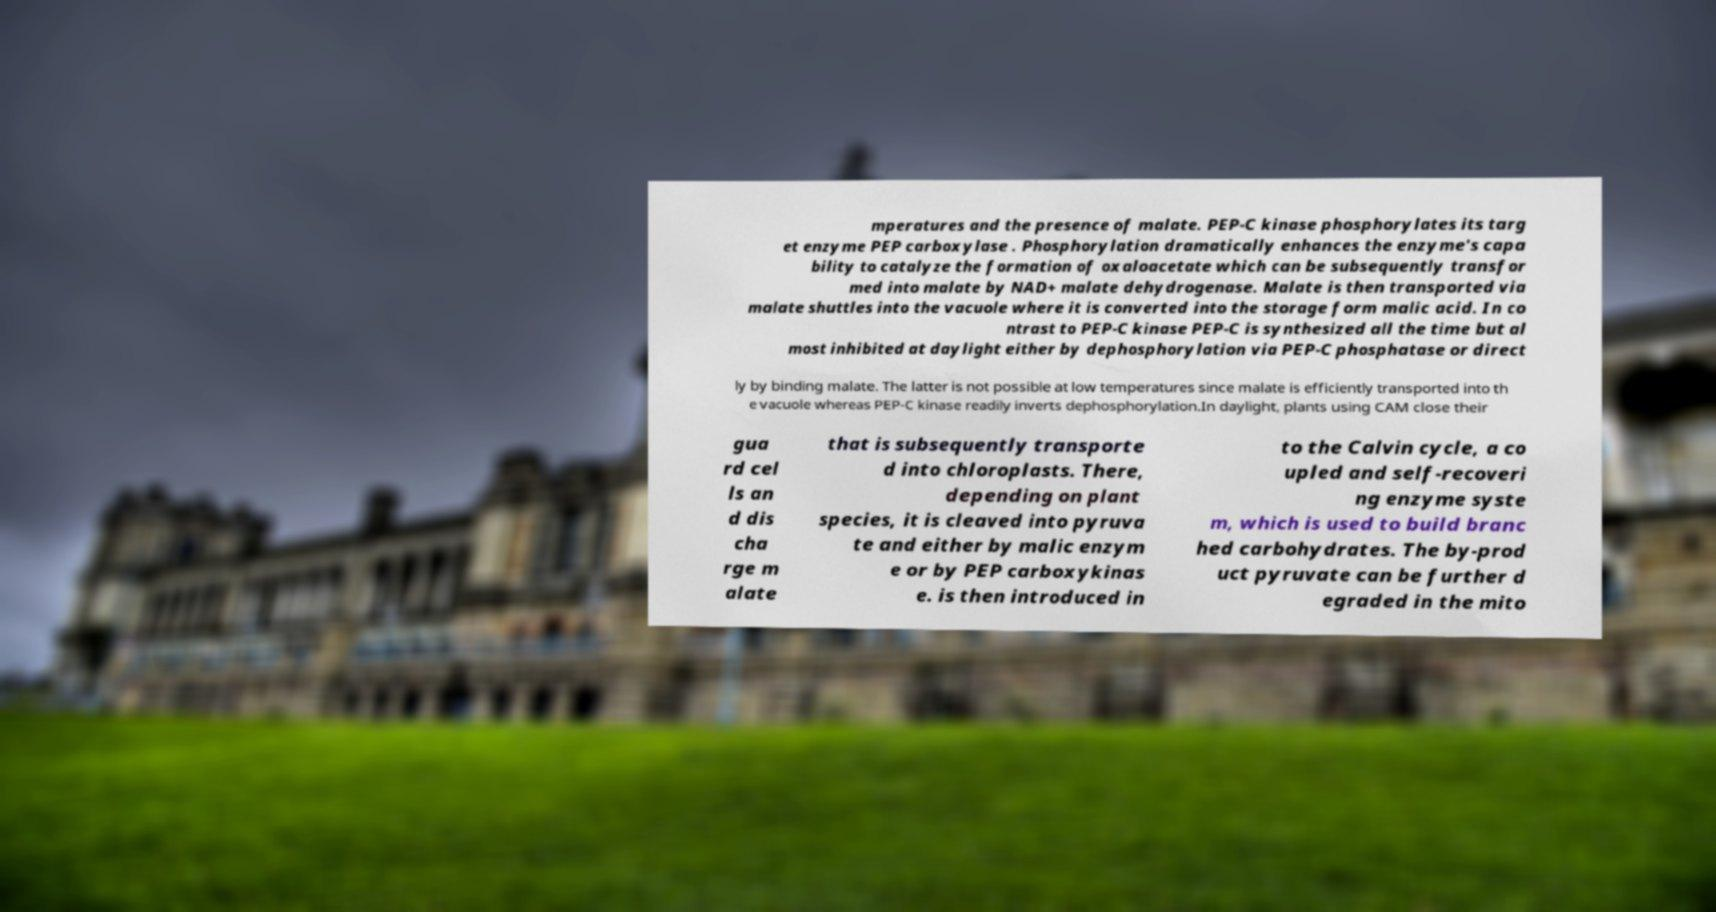Please identify and transcribe the text found in this image. mperatures and the presence of malate. PEP-C kinase phosphorylates its targ et enzyme PEP carboxylase . Phosphorylation dramatically enhances the enzyme's capa bility to catalyze the formation of oxaloacetate which can be subsequently transfor med into malate by NAD+ malate dehydrogenase. Malate is then transported via malate shuttles into the vacuole where it is converted into the storage form malic acid. In co ntrast to PEP-C kinase PEP-C is synthesized all the time but al most inhibited at daylight either by dephosphorylation via PEP-C phosphatase or direct ly by binding malate. The latter is not possible at low temperatures since malate is efficiently transported into th e vacuole whereas PEP-C kinase readily inverts dephosphorylation.In daylight, plants using CAM close their gua rd cel ls an d dis cha rge m alate that is subsequently transporte d into chloroplasts. There, depending on plant species, it is cleaved into pyruva te and either by malic enzym e or by PEP carboxykinas e. is then introduced in to the Calvin cycle, a co upled and self-recoveri ng enzyme syste m, which is used to build branc hed carbohydrates. The by-prod uct pyruvate can be further d egraded in the mito 